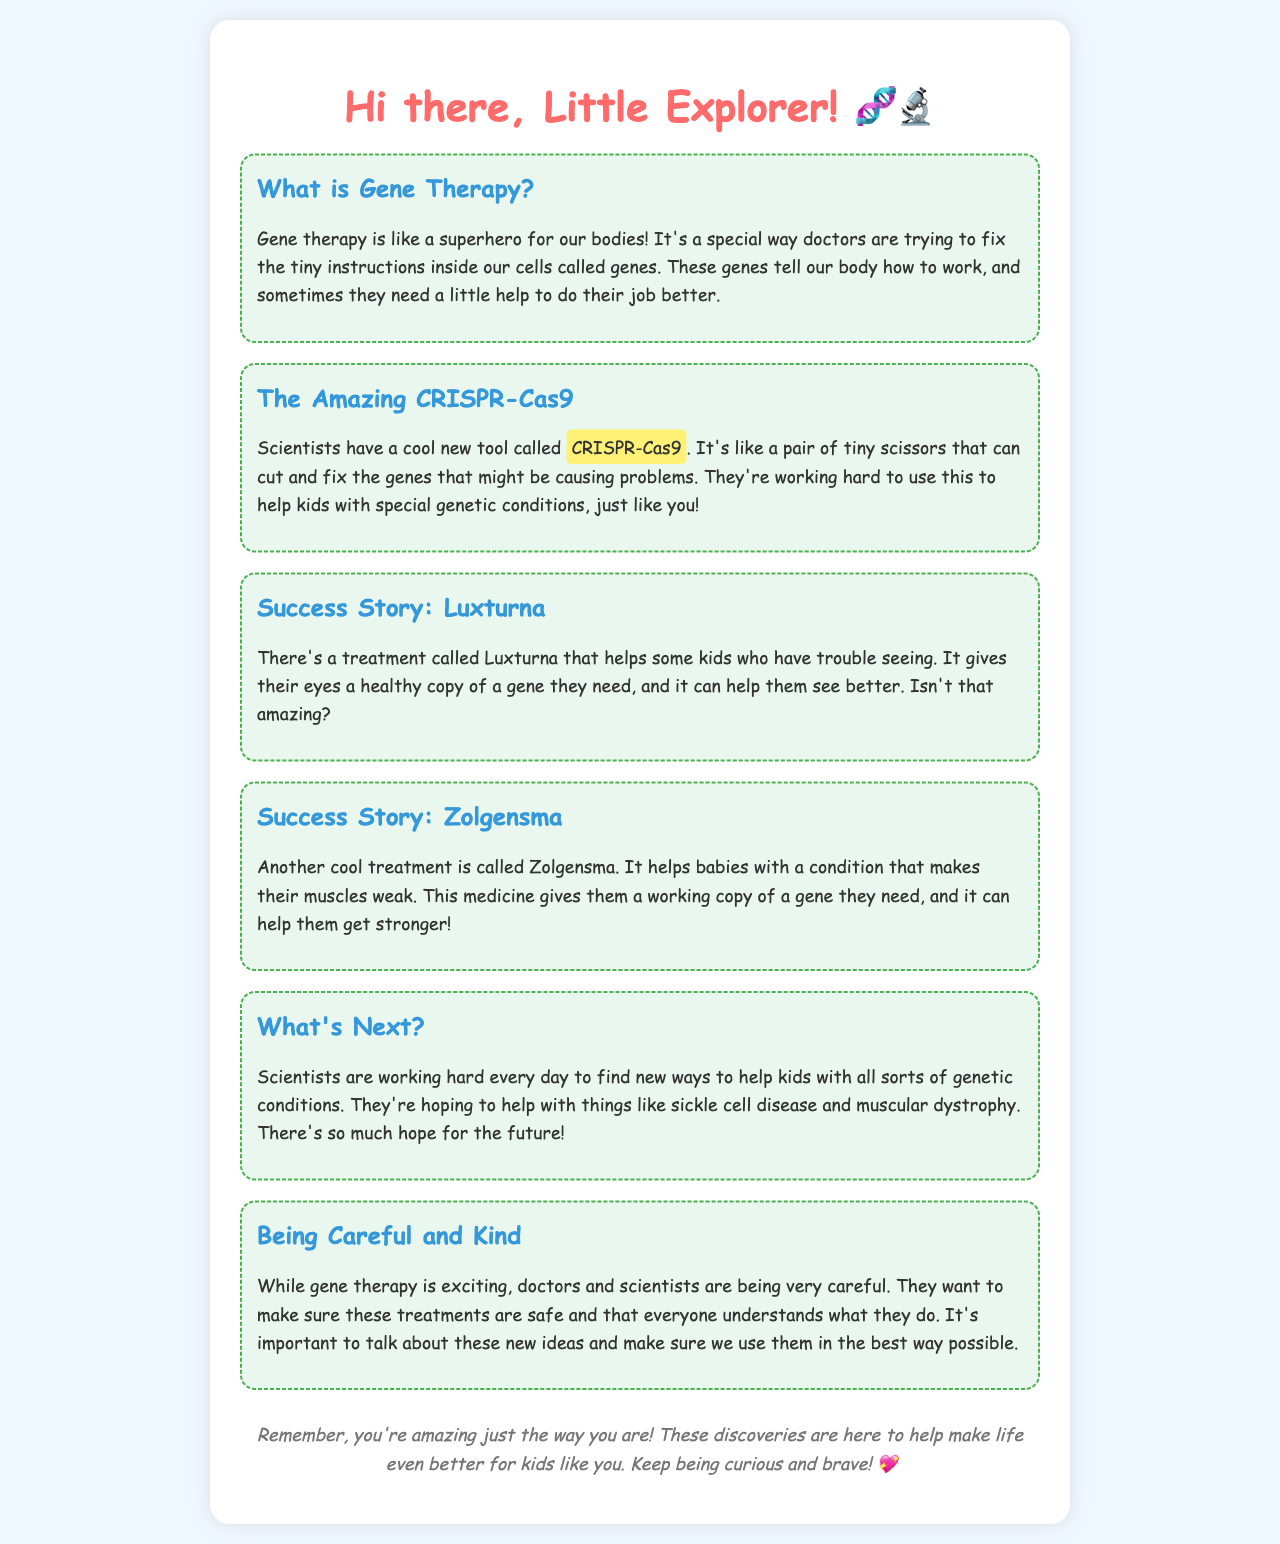What is gene therapy? Gene therapy is described as a special way doctors are trying to fix the tiny instructions inside our cells called genes.
Answer: A special way doctors are trying to fix the tiny instructions inside our cells called genes What is CRISPR-Cas9? CRISPR-Cas9 is referred to as a cool new tool that scientists use, likened to a pair of tiny scissors that can cut and fix genes.
Answer: A pair of tiny scissors What does Luxturna help with? Luxturna is a treatment that helps kids who have trouble seeing by giving their eyes a healthy copy of a gene they need.
Answer: Trouble seeing What condition does Zolgensma treat? Zolgensma helps babies with a condition that makes their muscles weak.
Answer: A condition that makes their muscles weak What future conditions are scientists hoping to help with? Scientists are hoping to help with things like sickle cell disease and muscular dystrophy in the future.
Answer: Sickle cell disease and muscular dystrophy Why are scientists being careful with gene therapy? Scientists are being careful to ensure these treatments are safe and that everyone understands what they do.
Answer: To ensure these treatments are safe Who is the letter addressed to? The letter starts with "Hi there, Little Explorer!" indicating it is addressed to a young child.
Answer: Little Explorer What is the tone of the letter? The tone is friendly and encouraging, aiming to inspire curiosity and bravery in children about gene therapy.
Answer: Friendly and encouraging 